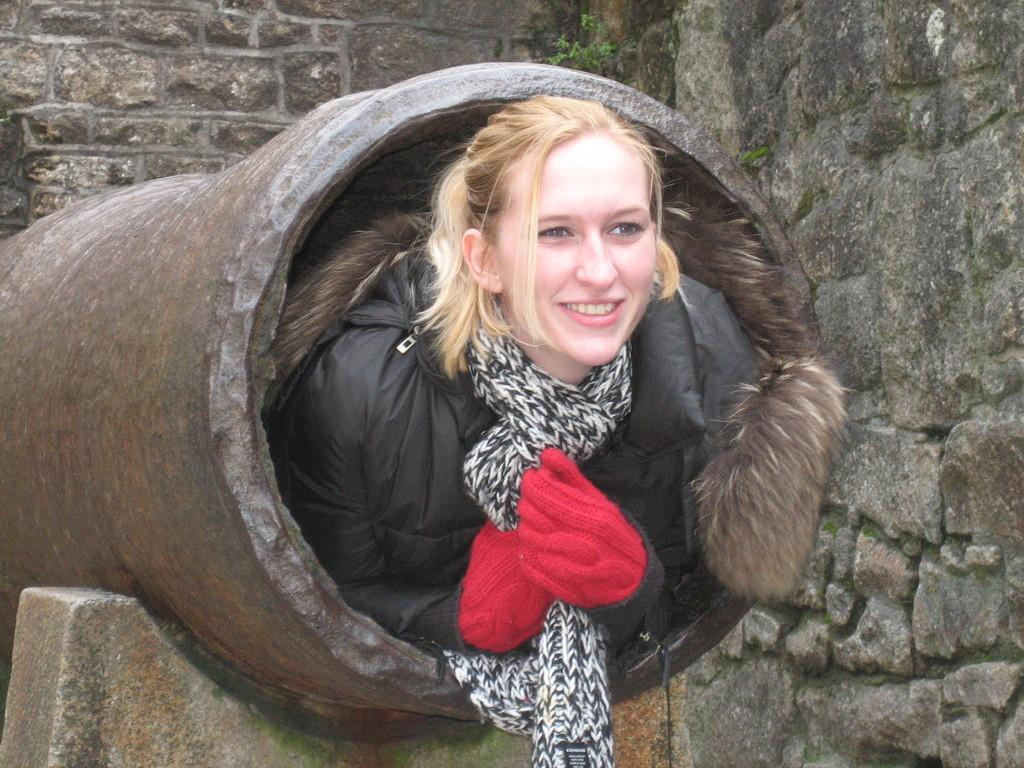Who or what is present in the image? There is a person in the image. Where is the person located? The person is inside a tunnel. What is the person wearing? The person is wearing clothes and gloves. What can be seen in the background of the image? There is a rock wall in the background of the image. What letters are being typed on the keyboard in the image? There is no keyboard or letters being typed in the image; the person is wearing gloves and is inside a tunnel. 